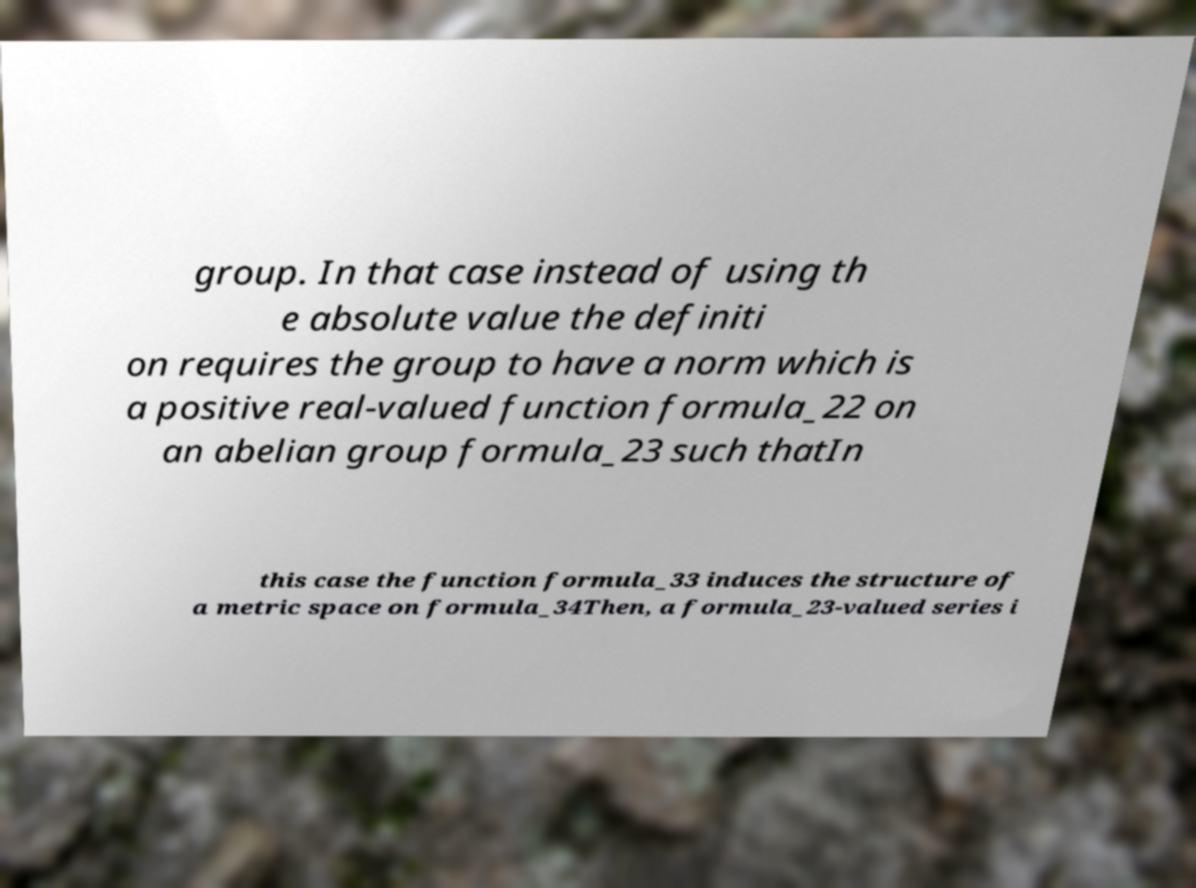I need the written content from this picture converted into text. Can you do that? group. In that case instead of using th e absolute value the definiti on requires the group to have a norm which is a positive real-valued function formula_22 on an abelian group formula_23 such thatIn this case the function formula_33 induces the structure of a metric space on formula_34Then, a formula_23-valued series i 